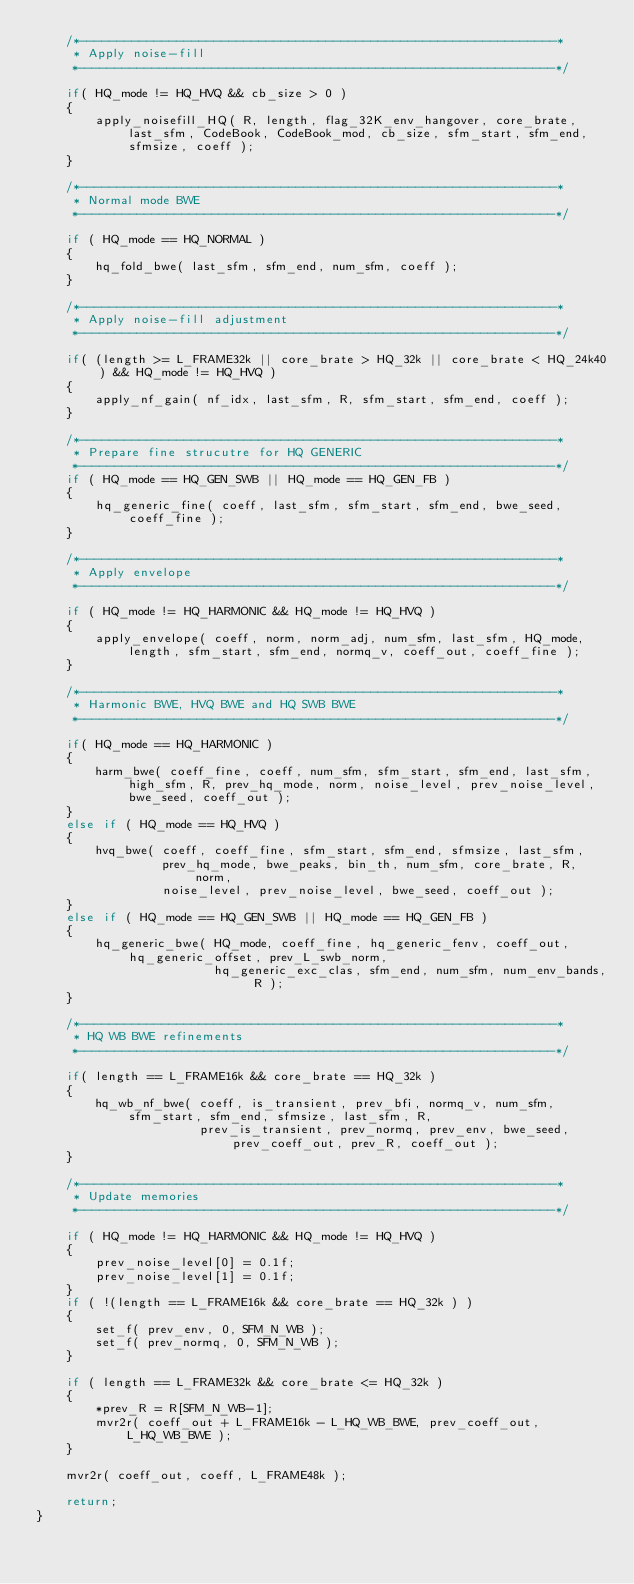<code> <loc_0><loc_0><loc_500><loc_500><_C_>    /*----------------------------------------------------------------*
     * Apply noise-fill
     *----------------------------------------------------------------*/

    if( HQ_mode != HQ_HVQ && cb_size > 0 )
    {
        apply_noisefill_HQ( R, length, flag_32K_env_hangover, core_brate, last_sfm, CodeBook, CodeBook_mod, cb_size, sfm_start, sfm_end, sfmsize, coeff );
    }

    /*----------------------------------------------------------------*
     * Normal mode BWE
     *----------------------------------------------------------------*/

    if ( HQ_mode == HQ_NORMAL )
    {
        hq_fold_bwe( last_sfm, sfm_end, num_sfm, coeff );
    }

    /*----------------------------------------------------------------*
     * Apply noise-fill adjustment
     *----------------------------------------------------------------*/

    if( (length >= L_FRAME32k || core_brate > HQ_32k || core_brate < HQ_24k40) && HQ_mode != HQ_HVQ )
    {
        apply_nf_gain( nf_idx, last_sfm, R, sfm_start, sfm_end, coeff );
    }

    /*----------------------------------------------------------------*
     * Prepare fine strucutre for HQ GENERIC
     *----------------------------------------------------------------*/
    if ( HQ_mode == HQ_GEN_SWB || HQ_mode == HQ_GEN_FB )
    {
        hq_generic_fine( coeff, last_sfm, sfm_start, sfm_end, bwe_seed, coeff_fine );
    }

    /*----------------------------------------------------------------*
     * Apply envelope
     *----------------------------------------------------------------*/

    if ( HQ_mode != HQ_HARMONIC && HQ_mode != HQ_HVQ )
    {
        apply_envelope( coeff, norm, norm_adj, num_sfm, last_sfm, HQ_mode, length, sfm_start, sfm_end, normq_v, coeff_out, coeff_fine );
    }

    /*----------------------------------------------------------------*
     * Harmonic BWE, HVQ BWE and HQ SWB BWE
     *----------------------------------------------------------------*/

    if( HQ_mode == HQ_HARMONIC )
    {
        harm_bwe( coeff_fine, coeff, num_sfm, sfm_start, sfm_end, last_sfm, high_sfm, R, prev_hq_mode, norm, noise_level, prev_noise_level, bwe_seed, coeff_out );
    }
    else if ( HQ_mode == HQ_HVQ )
    {
        hvq_bwe( coeff, coeff_fine, sfm_start, sfm_end, sfmsize, last_sfm,
                 prev_hq_mode, bwe_peaks, bin_th, num_sfm, core_brate, R, norm,
                 noise_level, prev_noise_level, bwe_seed, coeff_out );
    }
    else if ( HQ_mode == HQ_GEN_SWB || HQ_mode == HQ_GEN_FB )
    {
        hq_generic_bwe( HQ_mode, coeff_fine, hq_generic_fenv, coeff_out, hq_generic_offset, prev_L_swb_norm,
                        hq_generic_exc_clas, sfm_end, num_sfm, num_env_bands, R );
    }

    /*----------------------------------------------------------------*
     * HQ WB BWE refinements
     *----------------------------------------------------------------*/

    if( length == L_FRAME16k && core_brate == HQ_32k )
    {
        hq_wb_nf_bwe( coeff, is_transient, prev_bfi, normq_v, num_sfm, sfm_start, sfm_end, sfmsize, last_sfm, R,
                      prev_is_transient, prev_normq, prev_env, bwe_seed, prev_coeff_out, prev_R, coeff_out );
    }

    /*----------------------------------------------------------------*
     * Update memories
     *----------------------------------------------------------------*/

    if ( HQ_mode != HQ_HARMONIC && HQ_mode != HQ_HVQ )
    {
        prev_noise_level[0] = 0.1f;
        prev_noise_level[1] = 0.1f;
    }
    if ( !(length == L_FRAME16k && core_brate == HQ_32k ) )
    {
        set_f( prev_env, 0, SFM_N_WB );
        set_f( prev_normq, 0, SFM_N_WB );
    }

    if ( length == L_FRAME32k && core_brate <= HQ_32k )
    {
        *prev_R = R[SFM_N_WB-1];
        mvr2r( coeff_out + L_FRAME16k - L_HQ_WB_BWE, prev_coeff_out, L_HQ_WB_BWE );
    }

    mvr2r( coeff_out, coeff, L_FRAME48k );

    return;
}
</code> 